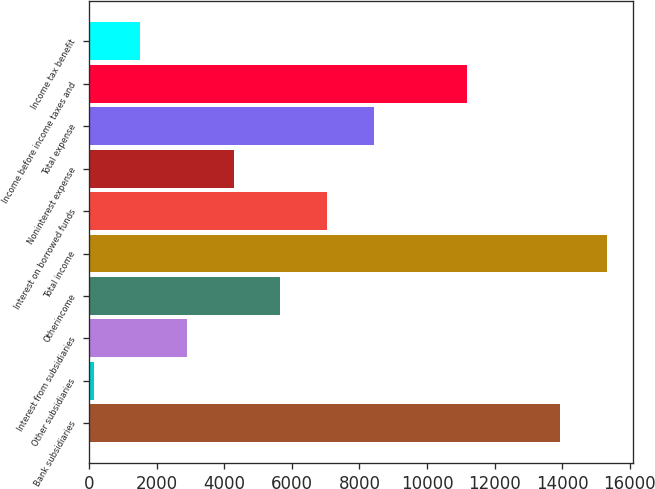<chart> <loc_0><loc_0><loc_500><loc_500><bar_chart><fcel>Bank subsidiaries<fcel>Other subsidiaries<fcel>Interest from subsidiaries<fcel>Otherincome<fcel>Total income<fcel>Interest on borrowed funds<fcel>Noninterest expense<fcel>Total expense<fcel>Income before income taxes and<fcel>Income tax benefit<nl><fcel>13947<fcel>133<fcel>2895.8<fcel>5658.6<fcel>15328.4<fcel>7040<fcel>4277.2<fcel>8421.4<fcel>11184.2<fcel>1514.4<nl></chart> 